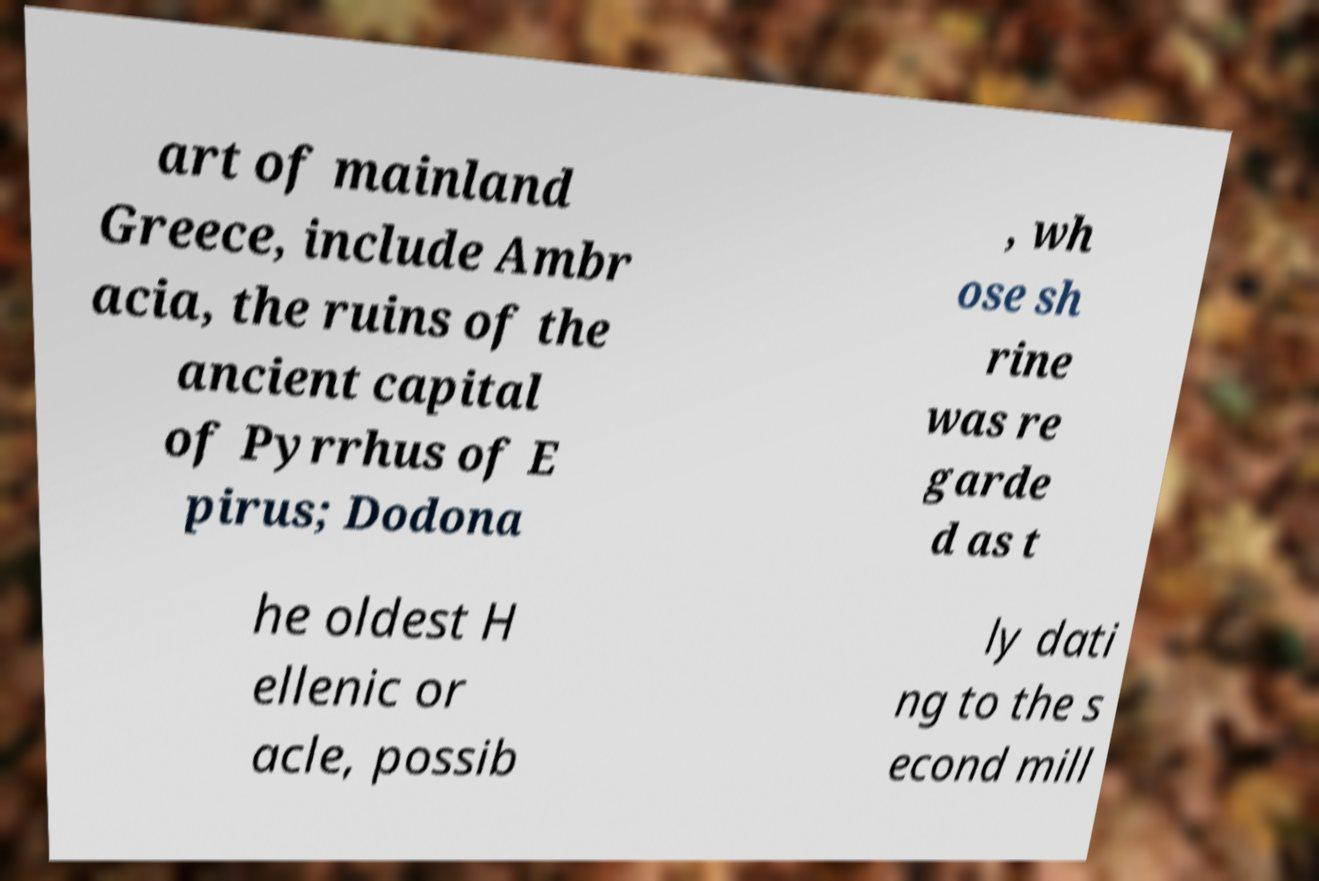Can you accurately transcribe the text from the provided image for me? art of mainland Greece, include Ambr acia, the ruins of the ancient capital of Pyrrhus of E pirus; Dodona , wh ose sh rine was re garde d as t he oldest H ellenic or acle, possib ly dati ng to the s econd mill 